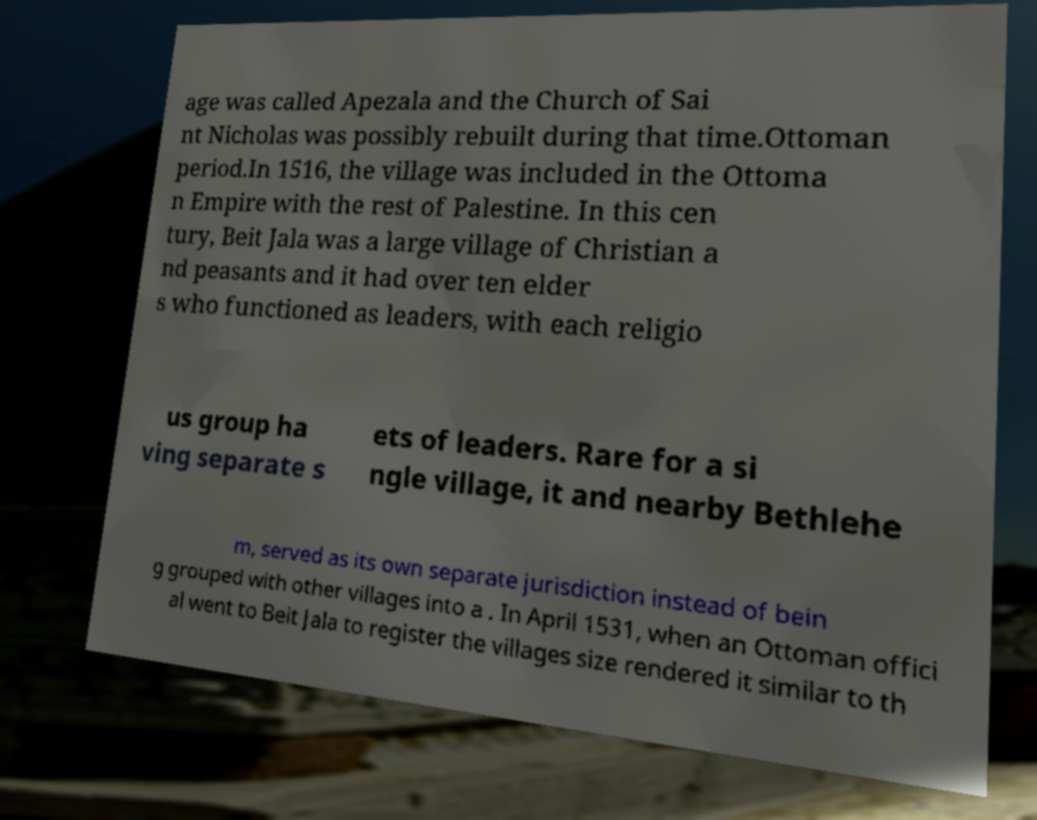There's text embedded in this image that I need extracted. Can you transcribe it verbatim? age was called Apezala and the Church of Sai nt Nicholas was possibly rebuilt during that time.Ottoman period.In 1516, the village was included in the Ottoma n Empire with the rest of Palestine. In this cen tury, Beit Jala was a large village of Christian a nd peasants and it had over ten elder s who functioned as leaders, with each religio us group ha ving separate s ets of leaders. Rare for a si ngle village, it and nearby Bethlehe m, served as its own separate jurisdiction instead of bein g grouped with other villages into a . In April 1531, when an Ottoman offici al went to Beit Jala to register the villages size rendered it similar to th 